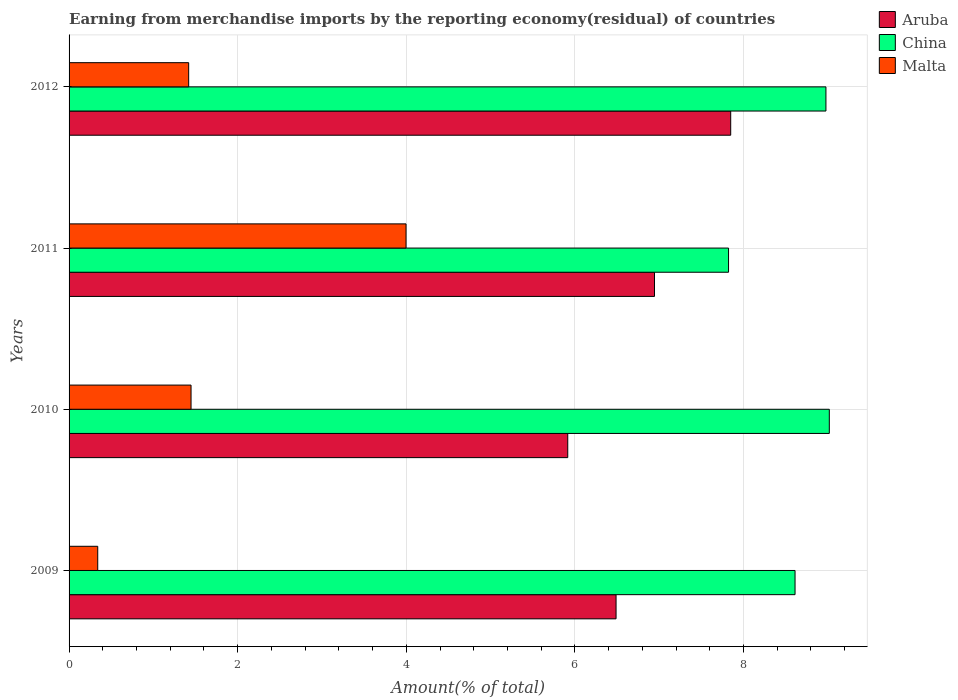How many different coloured bars are there?
Ensure brevity in your answer.  3. How many groups of bars are there?
Offer a very short reply. 4. Are the number of bars per tick equal to the number of legend labels?
Provide a short and direct response. Yes. How many bars are there on the 2nd tick from the top?
Your answer should be very brief. 3. How many bars are there on the 2nd tick from the bottom?
Provide a succinct answer. 3. What is the label of the 4th group of bars from the top?
Make the answer very short. 2009. What is the percentage of amount earned from merchandise imports in Aruba in 2012?
Give a very brief answer. 7.85. Across all years, what is the maximum percentage of amount earned from merchandise imports in Aruba?
Provide a short and direct response. 7.85. Across all years, what is the minimum percentage of amount earned from merchandise imports in Aruba?
Provide a succinct answer. 5.92. In which year was the percentage of amount earned from merchandise imports in Aruba minimum?
Your answer should be compact. 2010. What is the total percentage of amount earned from merchandise imports in Malta in the graph?
Provide a short and direct response. 7.2. What is the difference between the percentage of amount earned from merchandise imports in Malta in 2009 and that in 2011?
Your response must be concise. -3.66. What is the difference between the percentage of amount earned from merchandise imports in Aruba in 2010 and the percentage of amount earned from merchandise imports in Malta in 2011?
Make the answer very short. 1.92. What is the average percentage of amount earned from merchandise imports in Aruba per year?
Provide a short and direct response. 6.8. In the year 2009, what is the difference between the percentage of amount earned from merchandise imports in Malta and percentage of amount earned from merchandise imports in China?
Ensure brevity in your answer.  -8.27. What is the ratio of the percentage of amount earned from merchandise imports in Malta in 2010 to that in 2011?
Offer a terse response. 0.36. Is the percentage of amount earned from merchandise imports in China in 2009 less than that in 2012?
Offer a very short reply. Yes. Is the difference between the percentage of amount earned from merchandise imports in Malta in 2009 and 2010 greater than the difference between the percentage of amount earned from merchandise imports in China in 2009 and 2010?
Make the answer very short. No. What is the difference between the highest and the second highest percentage of amount earned from merchandise imports in China?
Make the answer very short. 0.04. What is the difference between the highest and the lowest percentage of amount earned from merchandise imports in China?
Give a very brief answer. 1.2. Is the sum of the percentage of amount earned from merchandise imports in Aruba in 2009 and 2012 greater than the maximum percentage of amount earned from merchandise imports in Malta across all years?
Provide a short and direct response. Yes. What does the 2nd bar from the bottom in 2012 represents?
Make the answer very short. China. How many bars are there?
Your response must be concise. 12. Are all the bars in the graph horizontal?
Make the answer very short. Yes. How many years are there in the graph?
Your answer should be very brief. 4. Are the values on the major ticks of X-axis written in scientific E-notation?
Make the answer very short. No. Does the graph contain any zero values?
Your response must be concise. No. Does the graph contain grids?
Your answer should be compact. Yes. What is the title of the graph?
Provide a short and direct response. Earning from merchandise imports by the reporting economy(residual) of countries. Does "Latin America(developing only)" appear as one of the legend labels in the graph?
Provide a succinct answer. No. What is the label or title of the X-axis?
Offer a terse response. Amount(% of total). What is the Amount(% of total) in Aruba in 2009?
Offer a very short reply. 6.49. What is the Amount(% of total) of China in 2009?
Your answer should be compact. 8.61. What is the Amount(% of total) of Malta in 2009?
Offer a terse response. 0.34. What is the Amount(% of total) of Aruba in 2010?
Ensure brevity in your answer.  5.92. What is the Amount(% of total) of China in 2010?
Your answer should be compact. 9.02. What is the Amount(% of total) in Malta in 2010?
Make the answer very short. 1.45. What is the Amount(% of total) of Aruba in 2011?
Give a very brief answer. 6.94. What is the Amount(% of total) of China in 2011?
Your answer should be compact. 7.82. What is the Amount(% of total) in Malta in 2011?
Give a very brief answer. 4. What is the Amount(% of total) of Aruba in 2012?
Your answer should be compact. 7.85. What is the Amount(% of total) in China in 2012?
Make the answer very short. 8.98. What is the Amount(% of total) in Malta in 2012?
Offer a very short reply. 1.42. Across all years, what is the maximum Amount(% of total) in Aruba?
Keep it short and to the point. 7.85. Across all years, what is the maximum Amount(% of total) in China?
Your response must be concise. 9.02. Across all years, what is the maximum Amount(% of total) in Malta?
Give a very brief answer. 4. Across all years, what is the minimum Amount(% of total) in Aruba?
Your response must be concise. 5.92. Across all years, what is the minimum Amount(% of total) of China?
Keep it short and to the point. 7.82. Across all years, what is the minimum Amount(% of total) in Malta?
Offer a terse response. 0.34. What is the total Amount(% of total) of Aruba in the graph?
Offer a terse response. 27.2. What is the total Amount(% of total) in China in the graph?
Keep it short and to the point. 34.43. What is the total Amount(% of total) in Malta in the graph?
Provide a short and direct response. 7.2. What is the difference between the Amount(% of total) in Aruba in 2009 and that in 2010?
Offer a terse response. 0.57. What is the difference between the Amount(% of total) in China in 2009 and that in 2010?
Keep it short and to the point. -0.41. What is the difference between the Amount(% of total) of Malta in 2009 and that in 2010?
Provide a succinct answer. -1.11. What is the difference between the Amount(% of total) of Aruba in 2009 and that in 2011?
Make the answer very short. -0.46. What is the difference between the Amount(% of total) in China in 2009 and that in 2011?
Provide a succinct answer. 0.79. What is the difference between the Amount(% of total) of Malta in 2009 and that in 2011?
Your answer should be compact. -3.66. What is the difference between the Amount(% of total) in Aruba in 2009 and that in 2012?
Your answer should be very brief. -1.36. What is the difference between the Amount(% of total) in China in 2009 and that in 2012?
Your response must be concise. -0.37. What is the difference between the Amount(% of total) of Malta in 2009 and that in 2012?
Your response must be concise. -1.08. What is the difference between the Amount(% of total) in Aruba in 2010 and that in 2011?
Provide a short and direct response. -1.03. What is the difference between the Amount(% of total) in China in 2010 and that in 2011?
Keep it short and to the point. 1.2. What is the difference between the Amount(% of total) in Malta in 2010 and that in 2011?
Offer a very short reply. -2.55. What is the difference between the Amount(% of total) of Aruba in 2010 and that in 2012?
Your answer should be compact. -1.93. What is the difference between the Amount(% of total) in China in 2010 and that in 2012?
Your answer should be compact. 0.04. What is the difference between the Amount(% of total) in Malta in 2010 and that in 2012?
Your answer should be very brief. 0.03. What is the difference between the Amount(% of total) of Aruba in 2011 and that in 2012?
Keep it short and to the point. -0.9. What is the difference between the Amount(% of total) of China in 2011 and that in 2012?
Ensure brevity in your answer.  -1.16. What is the difference between the Amount(% of total) in Malta in 2011 and that in 2012?
Give a very brief answer. 2.58. What is the difference between the Amount(% of total) in Aruba in 2009 and the Amount(% of total) in China in 2010?
Make the answer very short. -2.53. What is the difference between the Amount(% of total) of Aruba in 2009 and the Amount(% of total) of Malta in 2010?
Your response must be concise. 5.04. What is the difference between the Amount(% of total) of China in 2009 and the Amount(% of total) of Malta in 2010?
Ensure brevity in your answer.  7.16. What is the difference between the Amount(% of total) in Aruba in 2009 and the Amount(% of total) in China in 2011?
Offer a very short reply. -1.33. What is the difference between the Amount(% of total) in Aruba in 2009 and the Amount(% of total) in Malta in 2011?
Offer a terse response. 2.49. What is the difference between the Amount(% of total) of China in 2009 and the Amount(% of total) of Malta in 2011?
Offer a very short reply. 4.61. What is the difference between the Amount(% of total) of Aruba in 2009 and the Amount(% of total) of China in 2012?
Your answer should be very brief. -2.49. What is the difference between the Amount(% of total) of Aruba in 2009 and the Amount(% of total) of Malta in 2012?
Offer a very short reply. 5.07. What is the difference between the Amount(% of total) in China in 2009 and the Amount(% of total) in Malta in 2012?
Your answer should be compact. 7.19. What is the difference between the Amount(% of total) in Aruba in 2010 and the Amount(% of total) in China in 2011?
Your answer should be very brief. -1.91. What is the difference between the Amount(% of total) of Aruba in 2010 and the Amount(% of total) of Malta in 2011?
Offer a terse response. 1.92. What is the difference between the Amount(% of total) of China in 2010 and the Amount(% of total) of Malta in 2011?
Your answer should be very brief. 5.02. What is the difference between the Amount(% of total) of Aruba in 2010 and the Amount(% of total) of China in 2012?
Provide a short and direct response. -3.06. What is the difference between the Amount(% of total) of Aruba in 2010 and the Amount(% of total) of Malta in 2012?
Provide a succinct answer. 4.5. What is the difference between the Amount(% of total) of China in 2010 and the Amount(% of total) of Malta in 2012?
Offer a terse response. 7.6. What is the difference between the Amount(% of total) in Aruba in 2011 and the Amount(% of total) in China in 2012?
Make the answer very short. -2.03. What is the difference between the Amount(% of total) in Aruba in 2011 and the Amount(% of total) in Malta in 2012?
Provide a succinct answer. 5.53. What is the difference between the Amount(% of total) in China in 2011 and the Amount(% of total) in Malta in 2012?
Make the answer very short. 6.4. What is the average Amount(% of total) in Aruba per year?
Give a very brief answer. 6.8. What is the average Amount(% of total) of China per year?
Keep it short and to the point. 8.61. What is the average Amount(% of total) of Malta per year?
Your response must be concise. 1.8. In the year 2009, what is the difference between the Amount(% of total) in Aruba and Amount(% of total) in China?
Offer a terse response. -2.12. In the year 2009, what is the difference between the Amount(% of total) of Aruba and Amount(% of total) of Malta?
Your response must be concise. 6.15. In the year 2009, what is the difference between the Amount(% of total) of China and Amount(% of total) of Malta?
Make the answer very short. 8.27. In the year 2010, what is the difference between the Amount(% of total) of Aruba and Amount(% of total) of China?
Make the answer very short. -3.1. In the year 2010, what is the difference between the Amount(% of total) of Aruba and Amount(% of total) of Malta?
Offer a very short reply. 4.47. In the year 2010, what is the difference between the Amount(% of total) of China and Amount(% of total) of Malta?
Ensure brevity in your answer.  7.57. In the year 2011, what is the difference between the Amount(% of total) in Aruba and Amount(% of total) in China?
Your answer should be compact. -0.88. In the year 2011, what is the difference between the Amount(% of total) in Aruba and Amount(% of total) in Malta?
Make the answer very short. 2.95. In the year 2011, what is the difference between the Amount(% of total) of China and Amount(% of total) of Malta?
Make the answer very short. 3.83. In the year 2012, what is the difference between the Amount(% of total) of Aruba and Amount(% of total) of China?
Your answer should be very brief. -1.13. In the year 2012, what is the difference between the Amount(% of total) of Aruba and Amount(% of total) of Malta?
Provide a succinct answer. 6.43. In the year 2012, what is the difference between the Amount(% of total) of China and Amount(% of total) of Malta?
Ensure brevity in your answer.  7.56. What is the ratio of the Amount(% of total) in Aruba in 2009 to that in 2010?
Your answer should be very brief. 1.1. What is the ratio of the Amount(% of total) in China in 2009 to that in 2010?
Your answer should be compact. 0.95. What is the ratio of the Amount(% of total) in Malta in 2009 to that in 2010?
Offer a very short reply. 0.23. What is the ratio of the Amount(% of total) in Aruba in 2009 to that in 2011?
Make the answer very short. 0.93. What is the ratio of the Amount(% of total) in China in 2009 to that in 2011?
Provide a succinct answer. 1.1. What is the ratio of the Amount(% of total) of Malta in 2009 to that in 2011?
Make the answer very short. 0.09. What is the ratio of the Amount(% of total) of Aruba in 2009 to that in 2012?
Offer a terse response. 0.83. What is the ratio of the Amount(% of total) in China in 2009 to that in 2012?
Offer a terse response. 0.96. What is the ratio of the Amount(% of total) in Malta in 2009 to that in 2012?
Keep it short and to the point. 0.24. What is the ratio of the Amount(% of total) of Aruba in 2010 to that in 2011?
Your answer should be compact. 0.85. What is the ratio of the Amount(% of total) of China in 2010 to that in 2011?
Offer a very short reply. 1.15. What is the ratio of the Amount(% of total) of Malta in 2010 to that in 2011?
Provide a short and direct response. 0.36. What is the ratio of the Amount(% of total) in Aruba in 2010 to that in 2012?
Provide a short and direct response. 0.75. What is the ratio of the Amount(% of total) of China in 2010 to that in 2012?
Give a very brief answer. 1. What is the ratio of the Amount(% of total) of Malta in 2010 to that in 2012?
Make the answer very short. 1.02. What is the ratio of the Amount(% of total) of Aruba in 2011 to that in 2012?
Provide a short and direct response. 0.88. What is the ratio of the Amount(% of total) of China in 2011 to that in 2012?
Ensure brevity in your answer.  0.87. What is the ratio of the Amount(% of total) in Malta in 2011 to that in 2012?
Ensure brevity in your answer.  2.82. What is the difference between the highest and the second highest Amount(% of total) in Aruba?
Your answer should be compact. 0.9. What is the difference between the highest and the second highest Amount(% of total) in China?
Your answer should be compact. 0.04. What is the difference between the highest and the second highest Amount(% of total) in Malta?
Your answer should be very brief. 2.55. What is the difference between the highest and the lowest Amount(% of total) of Aruba?
Your response must be concise. 1.93. What is the difference between the highest and the lowest Amount(% of total) of China?
Give a very brief answer. 1.2. What is the difference between the highest and the lowest Amount(% of total) of Malta?
Ensure brevity in your answer.  3.66. 